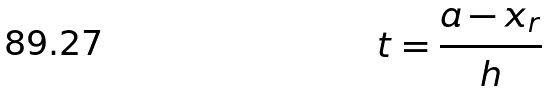<formula> <loc_0><loc_0><loc_500><loc_500>t = \frac { a - x _ { r } } { h }</formula> 